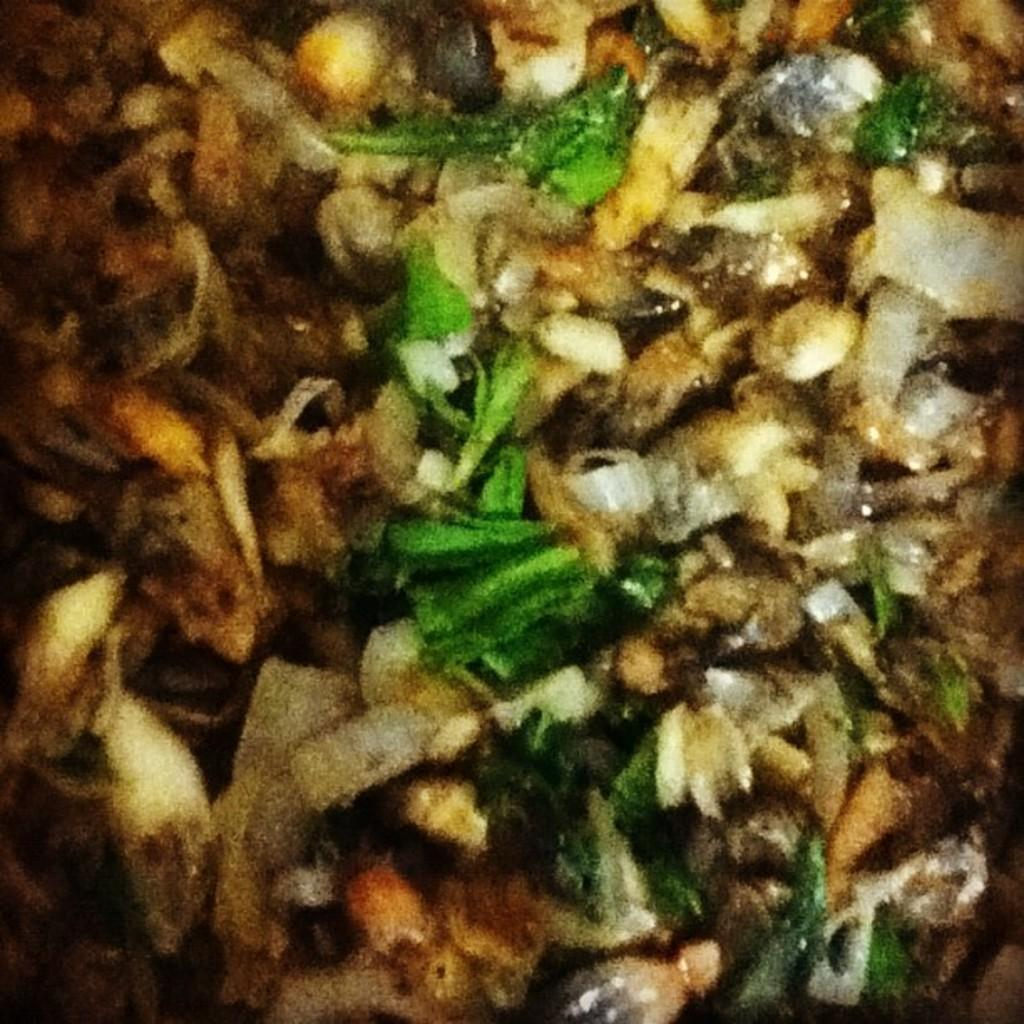What is present in the image? There is food in the image. What type of cheese is being used to read minds in the image? There is no cheese or mind-reading activity present in the image. 